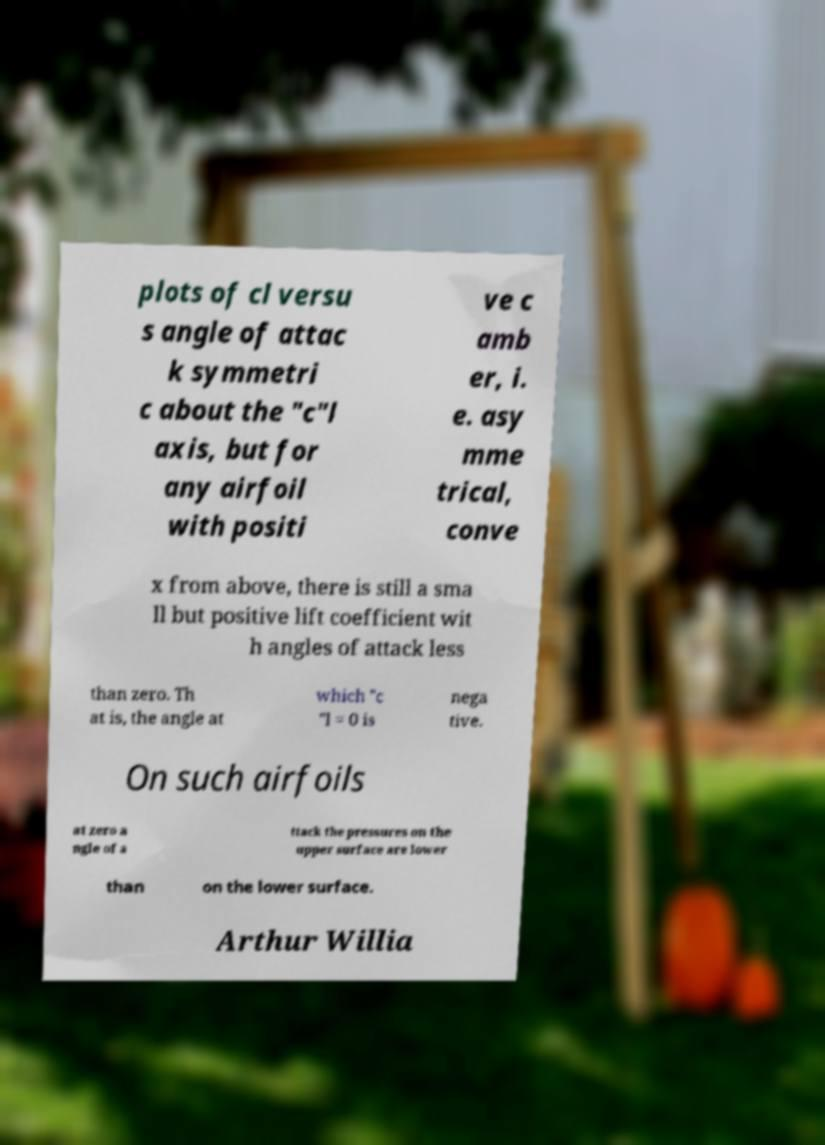What messages or text are displayed in this image? I need them in a readable, typed format. plots of cl versu s angle of attac k symmetri c about the "c"l axis, but for any airfoil with positi ve c amb er, i. e. asy mme trical, conve x from above, there is still a sma ll but positive lift coefficient wit h angles of attack less than zero. Th at is, the angle at which "c "l = 0 is nega tive. On such airfoils at zero a ngle of a ttack the pressures on the upper surface are lower than on the lower surface. Arthur Willia 